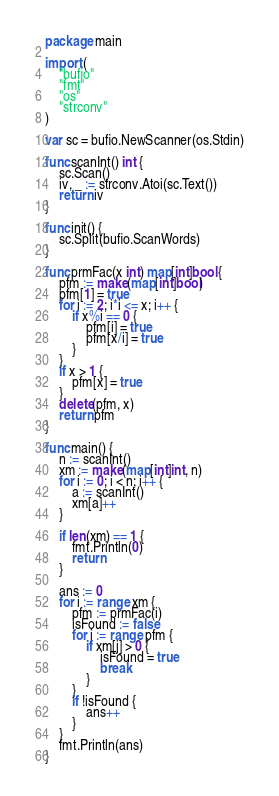<code> <loc_0><loc_0><loc_500><loc_500><_Go_>package main

import (
	"bufio"
	"fmt"
	"os"
	"strconv"
)

var sc = bufio.NewScanner(os.Stdin)

func scanInt() int {
	sc.Scan()
	iv, _ := strconv.Atoi(sc.Text())
	return iv
}

func init() {
	sc.Split(bufio.ScanWords)
}

func prmFac(x int) map[int]bool {
	pfm := make(map[int]bool)
	pfm[1] = true
	for i := 2; i*i <= x; i++ {
		if x%i == 0 {
			pfm[i] = true
			pfm[x/i] = true
		}
	}
	if x > 1 {
		pfm[x] = true
	}
	delete(pfm, x)
	return pfm
}

func main() {
	n := scanInt()
	xm := make(map[int]int, n)
	for i := 0; i < n; i++ {
		a := scanInt()
		xm[a]++
	}

	if len(xm) == 1 {
		fmt.Println(0)
		return
	}

	ans := 0
	for i := range xm {
		pfm := prmFac(i)
		isFound := false
		for j := range pfm {
			if xm[j] > 0 {
				isFound = true
				break
			}
		}
		if !isFound {
			ans++
		}
	}
	fmt.Println(ans)
}
</code> 